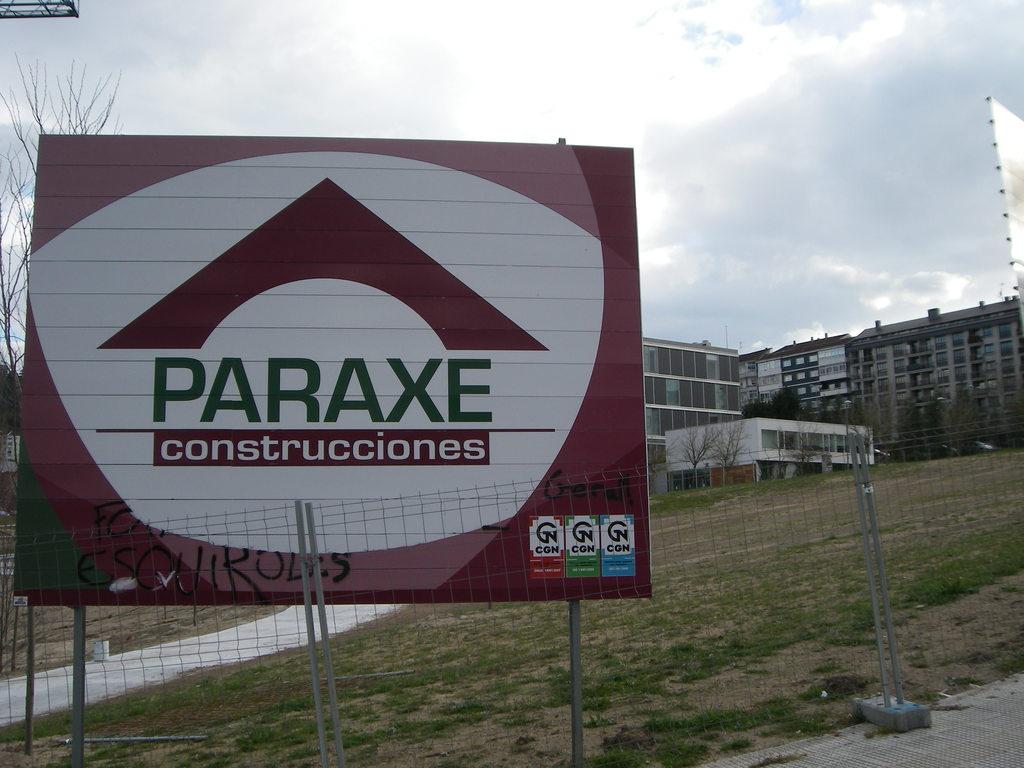What company is building on this land?
Make the answer very short. Paraxe. What word is in white and on a red background?
Ensure brevity in your answer.  Construcciones. 